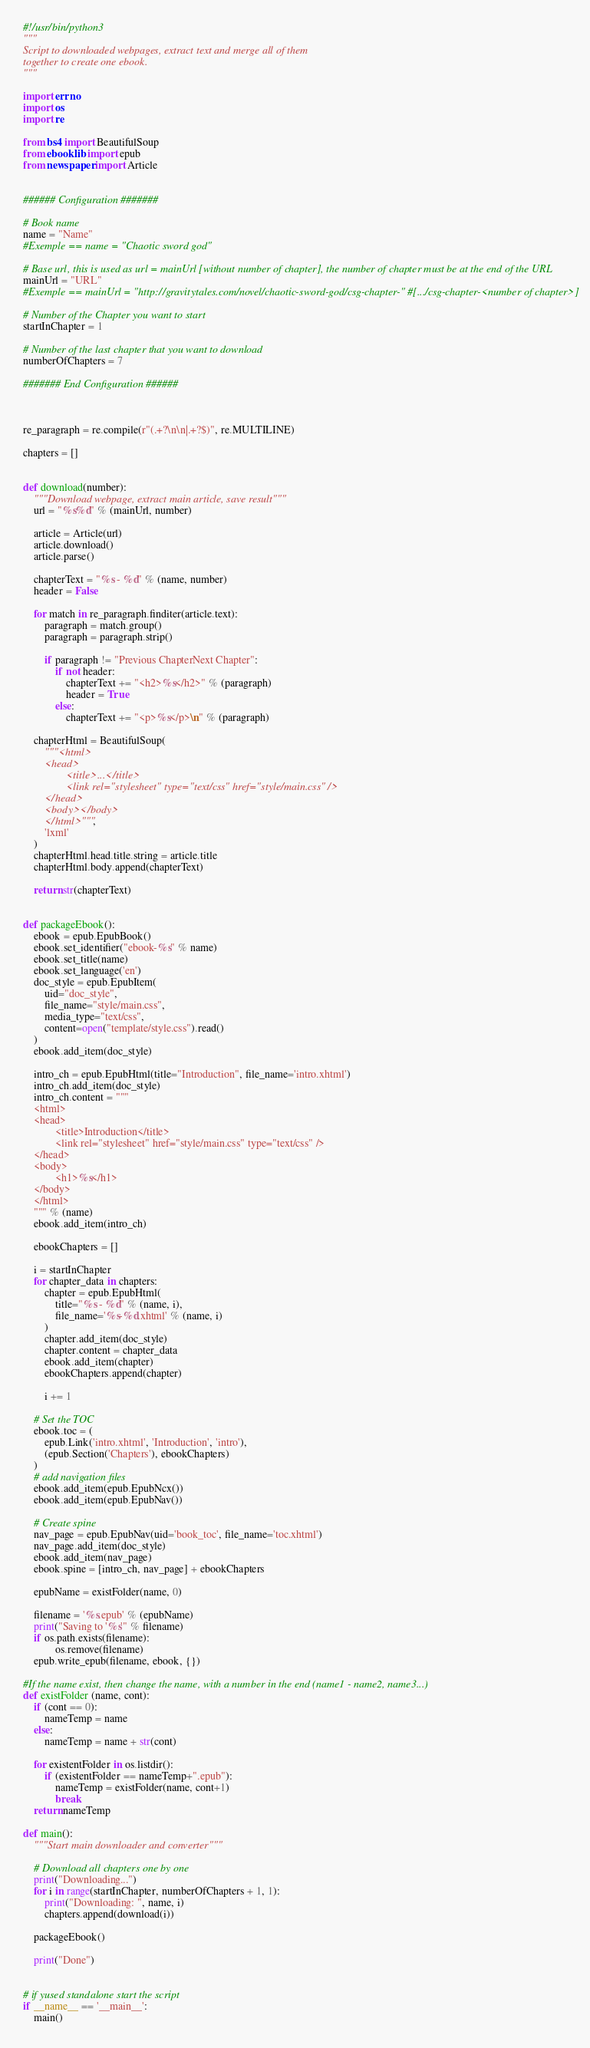<code> <loc_0><loc_0><loc_500><loc_500><_Python_>#!/usr/bin/python3
"""
Script to downloaded webpages, extract text and merge all of them
together to create one ebook.
"""

import errno
import os
import re

from bs4 import BeautifulSoup
from ebooklib import epub
from newspaper import Article


###### Configuration #######

# Book name
name = "Name"
#Exemple == name = "Chaotic sword god"

# Base url, this is used as url = mainUrl [without number of chapter], the number of chapter must be at the end of the URL
mainUrl = "URL"
#Exemple == mainUrl = "http://gravitytales.com/novel/chaotic-sword-god/csg-chapter-" #[.../csg-chapter-<number of chapter>]

# Number of the Chapter you want to start
startInChapter = 1

# Number of the last chapter that you want to download
numberOfChapters = 7

####### End Configuration ######



re_paragraph = re.compile(r"(.+?\n\n|.+?$)", re.MULTILINE)

chapters = []


def download(number):
	"""Download webpage, extract main article, save result"""
	url = "%s%d" % (mainUrl, number)

	article = Article(url)
	article.download()
	article.parse()

	chapterText = "%s - %d" % (name, number)
	header = False

	for match in re_paragraph.finditer(article.text):
		paragraph = match.group()
		paragraph = paragraph.strip()

		if paragraph != "Previous ChapterNext Chapter":
			if not header:
				chapterText += "<h2>%s</h2>" % (paragraph)
				header = True
			else:
				chapterText += "<p>%s</p>\n" % (paragraph)

	chapterHtml = BeautifulSoup(
		"""<html>
		<head>
				<title>...</title>
				<link rel="stylesheet" type="text/css" href="style/main.css" />
		</head>
		<body></body>
		</html>""",
		'lxml'
	)
	chapterHtml.head.title.string = article.title
	chapterHtml.body.append(chapterText)

	return str(chapterText)


def packageEbook():
	ebook = epub.EpubBook()
	ebook.set_identifier("ebook-%s" % name)
	ebook.set_title(name)
	ebook.set_language('en')
	doc_style = epub.EpubItem(
		uid="doc_style",
		file_name="style/main.css",
		media_type="text/css",
		content=open("template/style.css").read()
	)
	ebook.add_item(doc_style)

	intro_ch = epub.EpubHtml(title="Introduction", file_name='intro.xhtml')
	intro_ch.add_item(doc_style)
	intro_ch.content = """
	<html>
	<head>
			<title>Introduction</title>
			<link rel="stylesheet" href="style/main.css" type="text/css" />
	</head>
	<body>
			<h1>%s</h1>
	</body>
	</html>
	""" % (name)
	ebook.add_item(intro_ch)

	ebookChapters = []

	i = startInChapter
	for chapter_data in chapters:
		chapter = epub.EpubHtml(
			title="%s - %d" % (name, i),
			file_name='%s-%d.xhtml' % (name, i)
		)
		chapter.add_item(doc_style)
		chapter.content = chapter_data
		ebook.add_item(chapter)
		ebookChapters.append(chapter)

		i += 1

	# Set the TOC
	ebook.toc = (
		epub.Link('intro.xhtml', 'Introduction', 'intro'),
		(epub.Section('Chapters'), ebookChapters)
	)
	# add navigation files
	ebook.add_item(epub.EpubNcx())
	ebook.add_item(epub.EpubNav())

	# Create spine
	nav_page = epub.EpubNav(uid='book_toc', file_name='toc.xhtml')
	nav_page.add_item(doc_style)
	ebook.add_item(nav_page)
	ebook.spine = [intro_ch, nav_page] + ebookChapters

	epubName = existFolder(name, 0)

	filename = '%s.epub' % (epubName)
	print("Saving to '%s'" % filename)
	if os.path.exists(filename):
			os.remove(filename)
	epub.write_epub(filename, ebook, {})

#If the name exist, then change the name, with a number in the end (name1 - name2, name3...)
def existFolder (name, cont):
	if (cont == 0):
		nameTemp = name
	else:
		nameTemp = name + str(cont)

	for existentFolder in os.listdir():
		if (existentFolder == nameTemp+".epub"):
			nameTemp = existFolder(name, cont+1)
			break
	return nameTemp

def main():
	"""Start main downloader and converter"""

	# Download all chapters one by one
	print("Downloading...")
	for i in range(startInChapter, numberOfChapters + 1, 1):
		print("Downloading: ", name, i)
		chapters.append(download(i))

	packageEbook()

	print("Done")


# if yused standalone start the script
if __name__ == '__main__':
	main()
</code> 